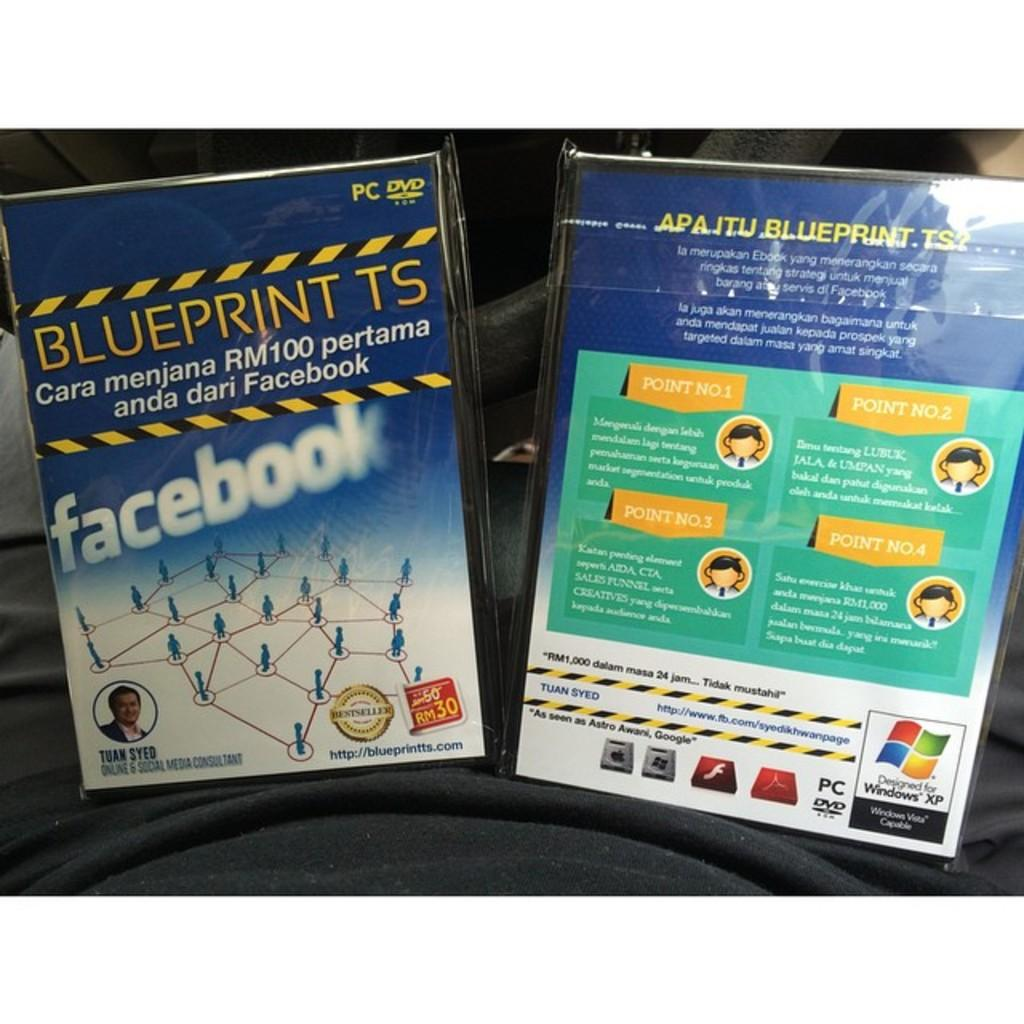<image>
Relay a brief, clear account of the picture shown. Two DVDs called Blueprint TS is on a black blanket. 